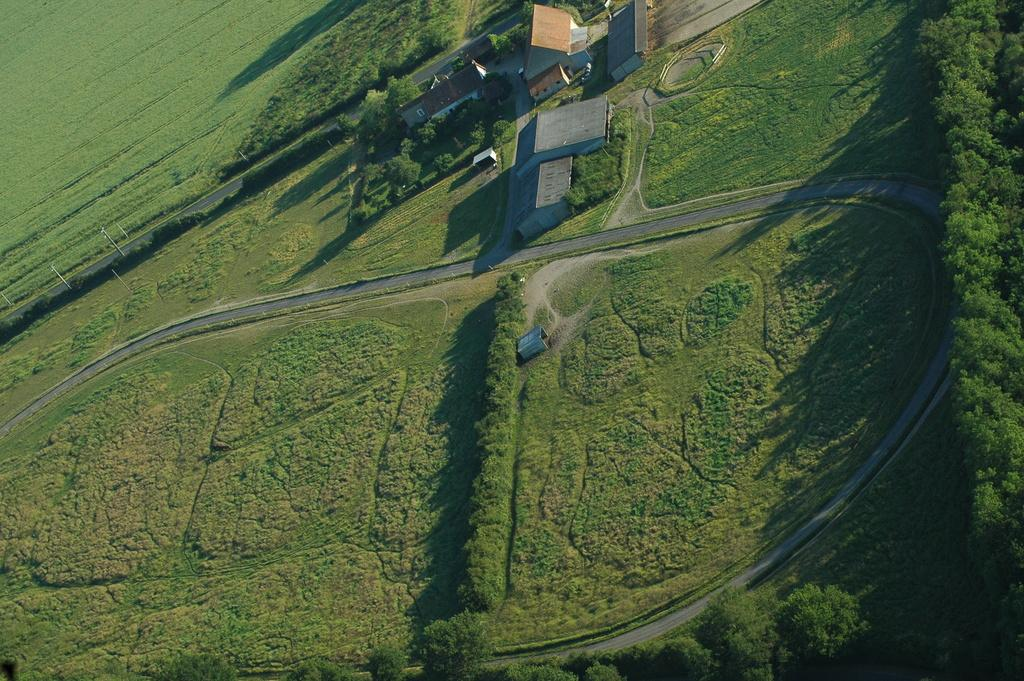What type of vegetation can be seen in the image? There is grass, plants, and trees in the image. What type of structures are visible in the image? There are houses in the image. What type of pathway is present in the image? There is a road in the image. Where is the jar of orange juice located in the image? There is no jar of orange juice present in the image. What type of bag is hanging on the tree in the image? There is no bag hanging on a tree in the image. 